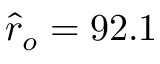<formula> <loc_0><loc_0><loc_500><loc_500>\hat { r } _ { o } = 9 2 . 1</formula> 